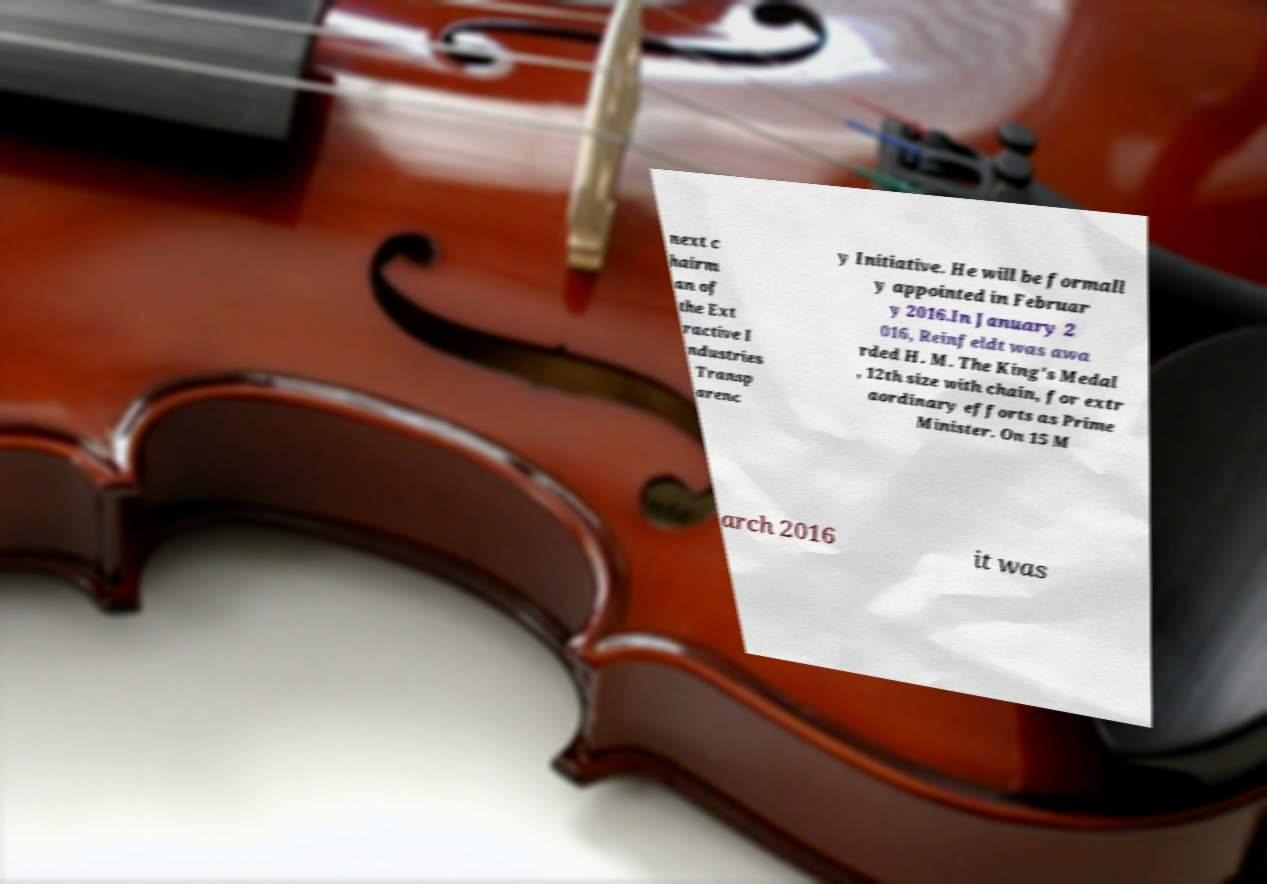Can you read and provide the text displayed in the image?This photo seems to have some interesting text. Can you extract and type it out for me? next c hairm an of the Ext ractive I ndustries Transp arenc y Initiative. He will be formall y appointed in Februar y 2016.In January 2 016, Reinfeldt was awa rded H. M. The King's Medal , 12th size with chain, for extr aordinary efforts as Prime Minister. On 15 M arch 2016 it was 